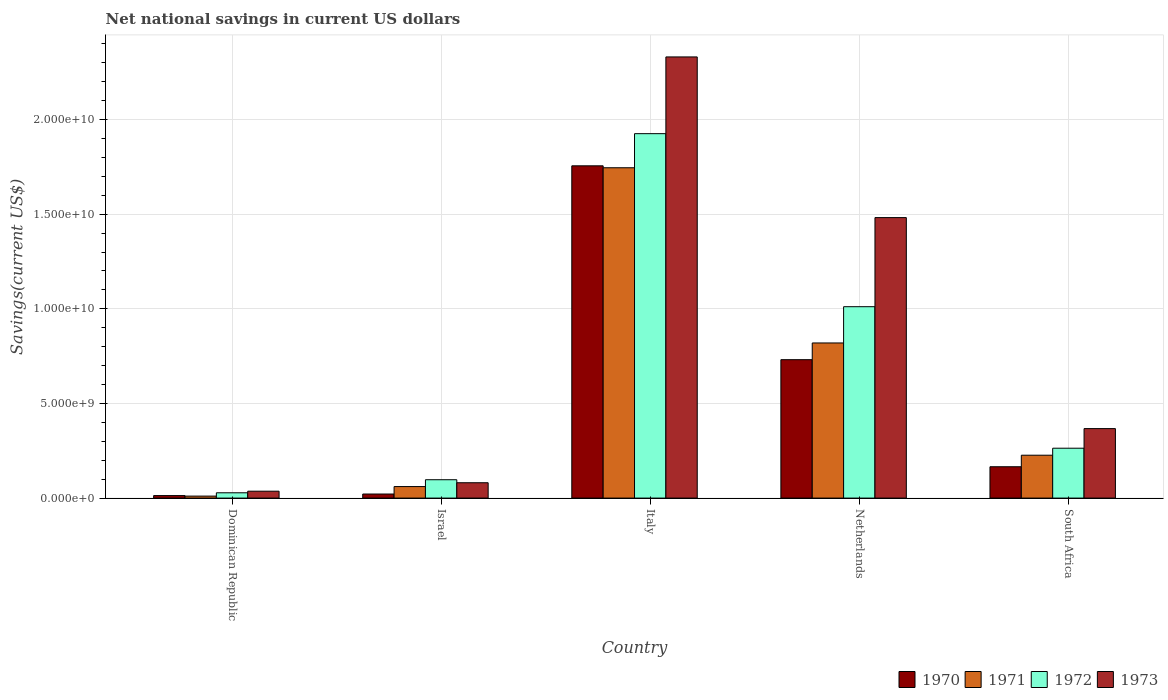How many different coloured bars are there?
Your answer should be compact. 4. How many groups of bars are there?
Offer a terse response. 5. How many bars are there on the 5th tick from the right?
Provide a short and direct response. 4. What is the label of the 1st group of bars from the left?
Your answer should be compact. Dominican Republic. In how many cases, is the number of bars for a given country not equal to the number of legend labels?
Your response must be concise. 0. What is the net national savings in 1972 in Italy?
Offer a very short reply. 1.93e+1. Across all countries, what is the maximum net national savings in 1972?
Ensure brevity in your answer.  1.93e+1. Across all countries, what is the minimum net national savings in 1972?
Offer a very short reply. 2.80e+08. In which country was the net national savings in 1973 maximum?
Your answer should be very brief. Italy. In which country was the net national savings in 1970 minimum?
Your response must be concise. Dominican Republic. What is the total net national savings in 1972 in the graph?
Make the answer very short. 3.33e+1. What is the difference between the net national savings in 1972 in Dominican Republic and that in Netherlands?
Your answer should be compact. -9.83e+09. What is the difference between the net national savings in 1970 in Italy and the net national savings in 1973 in Israel?
Your answer should be very brief. 1.67e+1. What is the average net national savings in 1973 per country?
Your answer should be compact. 8.59e+09. What is the difference between the net national savings of/in 1970 and net national savings of/in 1971 in Israel?
Ensure brevity in your answer.  -3.94e+08. In how many countries, is the net national savings in 1970 greater than 6000000000 US$?
Your response must be concise. 2. What is the ratio of the net national savings in 1971 in Israel to that in South Africa?
Your response must be concise. 0.27. Is the difference between the net national savings in 1970 in Dominican Republic and South Africa greater than the difference between the net national savings in 1971 in Dominican Republic and South Africa?
Offer a very short reply. Yes. What is the difference between the highest and the second highest net national savings in 1972?
Your answer should be very brief. -9.14e+09. What is the difference between the highest and the lowest net national savings in 1973?
Ensure brevity in your answer.  2.29e+1. What does the 1st bar from the left in Netherlands represents?
Offer a terse response. 1970. What does the 1st bar from the right in Dominican Republic represents?
Ensure brevity in your answer.  1973. How many bars are there?
Your response must be concise. 20. Are all the bars in the graph horizontal?
Your answer should be very brief. No. What is the difference between two consecutive major ticks on the Y-axis?
Provide a succinct answer. 5.00e+09. Are the values on the major ticks of Y-axis written in scientific E-notation?
Your answer should be very brief. Yes. Does the graph contain any zero values?
Offer a terse response. No. How many legend labels are there?
Your answer should be very brief. 4. How are the legend labels stacked?
Your response must be concise. Horizontal. What is the title of the graph?
Give a very brief answer. Net national savings in current US dollars. Does "1968" appear as one of the legend labels in the graph?
Offer a very short reply. No. What is the label or title of the Y-axis?
Your answer should be very brief. Savings(current US$). What is the Savings(current US$) in 1970 in Dominican Republic?
Your answer should be compact. 1.33e+08. What is the Savings(current US$) in 1971 in Dominican Republic?
Provide a short and direct response. 1.05e+08. What is the Savings(current US$) in 1972 in Dominican Republic?
Make the answer very short. 2.80e+08. What is the Savings(current US$) in 1973 in Dominican Republic?
Provide a short and direct response. 3.65e+08. What is the Savings(current US$) of 1970 in Israel?
Offer a terse response. 2.15e+08. What is the Savings(current US$) in 1971 in Israel?
Your answer should be very brief. 6.09e+08. What is the Savings(current US$) of 1972 in Israel?
Provide a succinct answer. 9.71e+08. What is the Savings(current US$) in 1973 in Israel?
Offer a terse response. 8.11e+08. What is the Savings(current US$) in 1970 in Italy?
Provide a succinct answer. 1.76e+1. What is the Savings(current US$) of 1971 in Italy?
Give a very brief answer. 1.75e+1. What is the Savings(current US$) in 1972 in Italy?
Provide a succinct answer. 1.93e+1. What is the Savings(current US$) in 1973 in Italy?
Make the answer very short. 2.33e+1. What is the Savings(current US$) of 1970 in Netherlands?
Offer a terse response. 7.31e+09. What is the Savings(current US$) in 1971 in Netherlands?
Provide a short and direct response. 8.20e+09. What is the Savings(current US$) of 1972 in Netherlands?
Offer a very short reply. 1.01e+1. What is the Savings(current US$) of 1973 in Netherlands?
Provide a short and direct response. 1.48e+1. What is the Savings(current US$) in 1970 in South Africa?
Make the answer very short. 1.66e+09. What is the Savings(current US$) of 1971 in South Africa?
Your answer should be very brief. 2.27e+09. What is the Savings(current US$) in 1972 in South Africa?
Make the answer very short. 2.64e+09. What is the Savings(current US$) in 1973 in South Africa?
Give a very brief answer. 3.67e+09. Across all countries, what is the maximum Savings(current US$) of 1970?
Give a very brief answer. 1.76e+1. Across all countries, what is the maximum Savings(current US$) in 1971?
Offer a very short reply. 1.75e+1. Across all countries, what is the maximum Savings(current US$) of 1972?
Provide a short and direct response. 1.93e+1. Across all countries, what is the maximum Savings(current US$) of 1973?
Offer a very short reply. 2.33e+1. Across all countries, what is the minimum Savings(current US$) in 1970?
Make the answer very short. 1.33e+08. Across all countries, what is the minimum Savings(current US$) of 1971?
Give a very brief answer. 1.05e+08. Across all countries, what is the minimum Savings(current US$) of 1972?
Make the answer very short. 2.80e+08. Across all countries, what is the minimum Savings(current US$) of 1973?
Your answer should be compact. 3.65e+08. What is the total Savings(current US$) of 1970 in the graph?
Provide a short and direct response. 2.69e+1. What is the total Savings(current US$) of 1971 in the graph?
Give a very brief answer. 2.86e+1. What is the total Savings(current US$) in 1972 in the graph?
Offer a very short reply. 3.33e+1. What is the total Savings(current US$) of 1973 in the graph?
Provide a short and direct response. 4.30e+1. What is the difference between the Savings(current US$) in 1970 in Dominican Republic and that in Israel?
Your answer should be very brief. -8.19e+07. What is the difference between the Savings(current US$) in 1971 in Dominican Republic and that in Israel?
Provide a succinct answer. -5.03e+08. What is the difference between the Savings(current US$) of 1972 in Dominican Republic and that in Israel?
Provide a succinct answer. -6.90e+08. What is the difference between the Savings(current US$) in 1973 in Dominican Republic and that in Israel?
Ensure brevity in your answer.  -4.46e+08. What is the difference between the Savings(current US$) in 1970 in Dominican Republic and that in Italy?
Your response must be concise. -1.74e+1. What is the difference between the Savings(current US$) of 1971 in Dominican Republic and that in Italy?
Provide a succinct answer. -1.73e+1. What is the difference between the Savings(current US$) of 1972 in Dominican Republic and that in Italy?
Offer a terse response. -1.90e+1. What is the difference between the Savings(current US$) of 1973 in Dominican Republic and that in Italy?
Give a very brief answer. -2.29e+1. What is the difference between the Savings(current US$) of 1970 in Dominican Republic and that in Netherlands?
Your answer should be very brief. -7.18e+09. What is the difference between the Savings(current US$) in 1971 in Dominican Republic and that in Netherlands?
Offer a very short reply. -8.09e+09. What is the difference between the Savings(current US$) in 1972 in Dominican Republic and that in Netherlands?
Make the answer very short. -9.83e+09. What is the difference between the Savings(current US$) in 1973 in Dominican Republic and that in Netherlands?
Your response must be concise. -1.45e+1. What is the difference between the Savings(current US$) of 1970 in Dominican Republic and that in South Africa?
Give a very brief answer. -1.52e+09. What is the difference between the Savings(current US$) of 1971 in Dominican Republic and that in South Africa?
Offer a terse response. -2.16e+09. What is the difference between the Savings(current US$) in 1972 in Dominican Republic and that in South Africa?
Give a very brief answer. -2.35e+09. What is the difference between the Savings(current US$) in 1973 in Dominican Republic and that in South Africa?
Your response must be concise. -3.31e+09. What is the difference between the Savings(current US$) of 1970 in Israel and that in Italy?
Keep it short and to the point. -1.73e+1. What is the difference between the Savings(current US$) in 1971 in Israel and that in Italy?
Your answer should be compact. -1.68e+1. What is the difference between the Savings(current US$) of 1972 in Israel and that in Italy?
Offer a very short reply. -1.83e+1. What is the difference between the Savings(current US$) in 1973 in Israel and that in Italy?
Make the answer very short. -2.25e+1. What is the difference between the Savings(current US$) in 1970 in Israel and that in Netherlands?
Provide a succinct answer. -7.10e+09. What is the difference between the Savings(current US$) of 1971 in Israel and that in Netherlands?
Provide a succinct answer. -7.59e+09. What is the difference between the Savings(current US$) of 1972 in Israel and that in Netherlands?
Give a very brief answer. -9.14e+09. What is the difference between the Savings(current US$) of 1973 in Israel and that in Netherlands?
Offer a terse response. -1.40e+1. What is the difference between the Savings(current US$) in 1970 in Israel and that in South Africa?
Ensure brevity in your answer.  -1.44e+09. What is the difference between the Savings(current US$) of 1971 in Israel and that in South Africa?
Provide a short and direct response. -1.66e+09. What is the difference between the Savings(current US$) in 1972 in Israel and that in South Africa?
Your response must be concise. -1.66e+09. What is the difference between the Savings(current US$) of 1973 in Israel and that in South Africa?
Keep it short and to the point. -2.86e+09. What is the difference between the Savings(current US$) of 1970 in Italy and that in Netherlands?
Offer a terse response. 1.02e+1. What is the difference between the Savings(current US$) of 1971 in Italy and that in Netherlands?
Offer a terse response. 9.26e+09. What is the difference between the Savings(current US$) of 1972 in Italy and that in Netherlands?
Give a very brief answer. 9.14e+09. What is the difference between the Savings(current US$) in 1973 in Italy and that in Netherlands?
Your response must be concise. 8.49e+09. What is the difference between the Savings(current US$) in 1970 in Italy and that in South Africa?
Offer a terse response. 1.59e+1. What is the difference between the Savings(current US$) of 1971 in Italy and that in South Africa?
Offer a terse response. 1.52e+1. What is the difference between the Savings(current US$) of 1972 in Italy and that in South Africa?
Your response must be concise. 1.66e+1. What is the difference between the Savings(current US$) in 1973 in Italy and that in South Africa?
Your response must be concise. 1.96e+1. What is the difference between the Savings(current US$) of 1970 in Netherlands and that in South Africa?
Make the answer very short. 5.66e+09. What is the difference between the Savings(current US$) of 1971 in Netherlands and that in South Africa?
Make the answer very short. 5.93e+09. What is the difference between the Savings(current US$) in 1972 in Netherlands and that in South Africa?
Provide a short and direct response. 7.48e+09. What is the difference between the Savings(current US$) in 1973 in Netherlands and that in South Africa?
Keep it short and to the point. 1.11e+1. What is the difference between the Savings(current US$) of 1970 in Dominican Republic and the Savings(current US$) of 1971 in Israel?
Your response must be concise. -4.76e+08. What is the difference between the Savings(current US$) of 1970 in Dominican Republic and the Savings(current US$) of 1972 in Israel?
Provide a short and direct response. -8.38e+08. What is the difference between the Savings(current US$) in 1970 in Dominican Republic and the Savings(current US$) in 1973 in Israel?
Your response must be concise. -6.78e+08. What is the difference between the Savings(current US$) of 1971 in Dominican Republic and the Savings(current US$) of 1972 in Israel?
Your response must be concise. -8.65e+08. What is the difference between the Savings(current US$) in 1971 in Dominican Republic and the Savings(current US$) in 1973 in Israel?
Give a very brief answer. -7.05e+08. What is the difference between the Savings(current US$) in 1972 in Dominican Republic and the Savings(current US$) in 1973 in Israel?
Offer a terse response. -5.30e+08. What is the difference between the Savings(current US$) of 1970 in Dominican Republic and the Savings(current US$) of 1971 in Italy?
Your answer should be compact. -1.73e+1. What is the difference between the Savings(current US$) in 1970 in Dominican Republic and the Savings(current US$) in 1972 in Italy?
Your response must be concise. -1.91e+1. What is the difference between the Savings(current US$) in 1970 in Dominican Republic and the Savings(current US$) in 1973 in Italy?
Offer a terse response. -2.32e+1. What is the difference between the Savings(current US$) in 1971 in Dominican Republic and the Savings(current US$) in 1972 in Italy?
Make the answer very short. -1.91e+1. What is the difference between the Savings(current US$) of 1971 in Dominican Republic and the Savings(current US$) of 1973 in Italy?
Make the answer very short. -2.32e+1. What is the difference between the Savings(current US$) in 1972 in Dominican Republic and the Savings(current US$) in 1973 in Italy?
Ensure brevity in your answer.  -2.30e+1. What is the difference between the Savings(current US$) of 1970 in Dominican Republic and the Savings(current US$) of 1971 in Netherlands?
Ensure brevity in your answer.  -8.06e+09. What is the difference between the Savings(current US$) in 1970 in Dominican Republic and the Savings(current US$) in 1972 in Netherlands?
Offer a very short reply. -9.98e+09. What is the difference between the Savings(current US$) in 1970 in Dominican Republic and the Savings(current US$) in 1973 in Netherlands?
Keep it short and to the point. -1.47e+1. What is the difference between the Savings(current US$) of 1971 in Dominican Republic and the Savings(current US$) of 1972 in Netherlands?
Keep it short and to the point. -1.00e+1. What is the difference between the Savings(current US$) in 1971 in Dominican Republic and the Savings(current US$) in 1973 in Netherlands?
Your answer should be very brief. -1.47e+1. What is the difference between the Savings(current US$) of 1972 in Dominican Republic and the Savings(current US$) of 1973 in Netherlands?
Your answer should be compact. -1.45e+1. What is the difference between the Savings(current US$) of 1970 in Dominican Republic and the Savings(current US$) of 1971 in South Africa?
Keep it short and to the point. -2.13e+09. What is the difference between the Savings(current US$) in 1970 in Dominican Republic and the Savings(current US$) in 1972 in South Africa?
Keep it short and to the point. -2.50e+09. What is the difference between the Savings(current US$) of 1970 in Dominican Republic and the Savings(current US$) of 1973 in South Africa?
Your answer should be compact. -3.54e+09. What is the difference between the Savings(current US$) in 1971 in Dominican Republic and the Savings(current US$) in 1972 in South Africa?
Provide a short and direct response. -2.53e+09. What is the difference between the Savings(current US$) of 1971 in Dominican Republic and the Savings(current US$) of 1973 in South Africa?
Provide a short and direct response. -3.57e+09. What is the difference between the Savings(current US$) of 1972 in Dominican Republic and the Savings(current US$) of 1973 in South Africa?
Your answer should be very brief. -3.39e+09. What is the difference between the Savings(current US$) in 1970 in Israel and the Savings(current US$) in 1971 in Italy?
Keep it short and to the point. -1.72e+1. What is the difference between the Savings(current US$) in 1970 in Israel and the Savings(current US$) in 1972 in Italy?
Your answer should be compact. -1.90e+1. What is the difference between the Savings(current US$) of 1970 in Israel and the Savings(current US$) of 1973 in Italy?
Provide a short and direct response. -2.31e+1. What is the difference between the Savings(current US$) in 1971 in Israel and the Savings(current US$) in 1972 in Italy?
Give a very brief answer. -1.86e+1. What is the difference between the Savings(current US$) of 1971 in Israel and the Savings(current US$) of 1973 in Italy?
Keep it short and to the point. -2.27e+1. What is the difference between the Savings(current US$) of 1972 in Israel and the Savings(current US$) of 1973 in Italy?
Keep it short and to the point. -2.23e+1. What is the difference between the Savings(current US$) of 1970 in Israel and the Savings(current US$) of 1971 in Netherlands?
Offer a terse response. -7.98e+09. What is the difference between the Savings(current US$) in 1970 in Israel and the Savings(current US$) in 1972 in Netherlands?
Give a very brief answer. -9.90e+09. What is the difference between the Savings(current US$) of 1970 in Israel and the Savings(current US$) of 1973 in Netherlands?
Ensure brevity in your answer.  -1.46e+1. What is the difference between the Savings(current US$) of 1971 in Israel and the Savings(current US$) of 1972 in Netherlands?
Your response must be concise. -9.50e+09. What is the difference between the Savings(current US$) of 1971 in Israel and the Savings(current US$) of 1973 in Netherlands?
Ensure brevity in your answer.  -1.42e+1. What is the difference between the Savings(current US$) in 1972 in Israel and the Savings(current US$) in 1973 in Netherlands?
Provide a short and direct response. -1.38e+1. What is the difference between the Savings(current US$) of 1970 in Israel and the Savings(current US$) of 1971 in South Africa?
Provide a short and direct response. -2.05e+09. What is the difference between the Savings(current US$) of 1970 in Israel and the Savings(current US$) of 1972 in South Africa?
Keep it short and to the point. -2.42e+09. What is the difference between the Savings(current US$) in 1970 in Israel and the Savings(current US$) in 1973 in South Africa?
Keep it short and to the point. -3.46e+09. What is the difference between the Savings(current US$) in 1971 in Israel and the Savings(current US$) in 1972 in South Africa?
Provide a short and direct response. -2.03e+09. What is the difference between the Savings(current US$) in 1971 in Israel and the Savings(current US$) in 1973 in South Africa?
Your response must be concise. -3.06e+09. What is the difference between the Savings(current US$) of 1972 in Israel and the Savings(current US$) of 1973 in South Africa?
Your answer should be very brief. -2.70e+09. What is the difference between the Savings(current US$) in 1970 in Italy and the Savings(current US$) in 1971 in Netherlands?
Your answer should be very brief. 9.36e+09. What is the difference between the Savings(current US$) of 1970 in Italy and the Savings(current US$) of 1972 in Netherlands?
Ensure brevity in your answer.  7.44e+09. What is the difference between the Savings(current US$) of 1970 in Italy and the Savings(current US$) of 1973 in Netherlands?
Ensure brevity in your answer.  2.74e+09. What is the difference between the Savings(current US$) of 1971 in Italy and the Savings(current US$) of 1972 in Netherlands?
Keep it short and to the point. 7.34e+09. What is the difference between the Savings(current US$) of 1971 in Italy and the Savings(current US$) of 1973 in Netherlands?
Your answer should be very brief. 2.63e+09. What is the difference between the Savings(current US$) in 1972 in Italy and the Savings(current US$) in 1973 in Netherlands?
Make the answer very short. 4.44e+09. What is the difference between the Savings(current US$) of 1970 in Italy and the Savings(current US$) of 1971 in South Africa?
Your answer should be compact. 1.53e+1. What is the difference between the Savings(current US$) of 1970 in Italy and the Savings(current US$) of 1972 in South Africa?
Provide a succinct answer. 1.49e+1. What is the difference between the Savings(current US$) in 1970 in Italy and the Savings(current US$) in 1973 in South Africa?
Provide a short and direct response. 1.39e+1. What is the difference between the Savings(current US$) in 1971 in Italy and the Savings(current US$) in 1972 in South Africa?
Your response must be concise. 1.48e+1. What is the difference between the Savings(current US$) of 1971 in Italy and the Savings(current US$) of 1973 in South Africa?
Make the answer very short. 1.38e+1. What is the difference between the Savings(current US$) of 1972 in Italy and the Savings(current US$) of 1973 in South Africa?
Offer a terse response. 1.56e+1. What is the difference between the Savings(current US$) of 1970 in Netherlands and the Savings(current US$) of 1971 in South Africa?
Make the answer very short. 5.05e+09. What is the difference between the Savings(current US$) in 1970 in Netherlands and the Savings(current US$) in 1972 in South Africa?
Offer a very short reply. 4.68e+09. What is the difference between the Savings(current US$) of 1970 in Netherlands and the Savings(current US$) of 1973 in South Africa?
Provide a short and direct response. 3.64e+09. What is the difference between the Savings(current US$) in 1971 in Netherlands and the Savings(current US$) in 1972 in South Africa?
Make the answer very short. 5.56e+09. What is the difference between the Savings(current US$) of 1971 in Netherlands and the Savings(current US$) of 1973 in South Africa?
Provide a short and direct response. 4.52e+09. What is the difference between the Savings(current US$) of 1972 in Netherlands and the Savings(current US$) of 1973 in South Africa?
Your answer should be very brief. 6.44e+09. What is the average Savings(current US$) in 1970 per country?
Your answer should be very brief. 5.37e+09. What is the average Savings(current US$) of 1971 per country?
Ensure brevity in your answer.  5.73e+09. What is the average Savings(current US$) in 1972 per country?
Make the answer very short. 6.65e+09. What is the average Savings(current US$) of 1973 per country?
Your response must be concise. 8.59e+09. What is the difference between the Savings(current US$) in 1970 and Savings(current US$) in 1971 in Dominican Republic?
Provide a short and direct response. 2.74e+07. What is the difference between the Savings(current US$) in 1970 and Savings(current US$) in 1972 in Dominican Republic?
Make the answer very short. -1.48e+08. What is the difference between the Savings(current US$) of 1970 and Savings(current US$) of 1973 in Dominican Republic?
Your response must be concise. -2.32e+08. What is the difference between the Savings(current US$) of 1971 and Savings(current US$) of 1972 in Dominican Republic?
Make the answer very short. -1.75e+08. What is the difference between the Savings(current US$) in 1971 and Savings(current US$) in 1973 in Dominican Republic?
Keep it short and to the point. -2.59e+08. What is the difference between the Savings(current US$) of 1972 and Savings(current US$) of 1973 in Dominican Republic?
Make the answer very short. -8.40e+07. What is the difference between the Savings(current US$) of 1970 and Savings(current US$) of 1971 in Israel?
Your response must be concise. -3.94e+08. What is the difference between the Savings(current US$) of 1970 and Savings(current US$) of 1972 in Israel?
Your answer should be very brief. -7.56e+08. What is the difference between the Savings(current US$) of 1970 and Savings(current US$) of 1973 in Israel?
Your answer should be very brief. -5.96e+08. What is the difference between the Savings(current US$) of 1971 and Savings(current US$) of 1972 in Israel?
Provide a short and direct response. -3.62e+08. What is the difference between the Savings(current US$) in 1971 and Savings(current US$) in 1973 in Israel?
Make the answer very short. -2.02e+08. What is the difference between the Savings(current US$) in 1972 and Savings(current US$) in 1973 in Israel?
Provide a short and direct response. 1.60e+08. What is the difference between the Savings(current US$) of 1970 and Savings(current US$) of 1971 in Italy?
Your answer should be compact. 1.03e+08. What is the difference between the Savings(current US$) in 1970 and Savings(current US$) in 1972 in Italy?
Provide a succinct answer. -1.70e+09. What is the difference between the Savings(current US$) in 1970 and Savings(current US$) in 1973 in Italy?
Make the answer very short. -5.75e+09. What is the difference between the Savings(current US$) in 1971 and Savings(current US$) in 1972 in Italy?
Your answer should be very brief. -1.80e+09. What is the difference between the Savings(current US$) in 1971 and Savings(current US$) in 1973 in Italy?
Your answer should be compact. -5.86e+09. What is the difference between the Savings(current US$) in 1972 and Savings(current US$) in 1973 in Italy?
Keep it short and to the point. -4.05e+09. What is the difference between the Savings(current US$) in 1970 and Savings(current US$) in 1971 in Netherlands?
Your response must be concise. -8.83e+08. What is the difference between the Savings(current US$) of 1970 and Savings(current US$) of 1972 in Netherlands?
Your answer should be compact. -2.80e+09. What is the difference between the Savings(current US$) in 1970 and Savings(current US$) in 1973 in Netherlands?
Ensure brevity in your answer.  -7.51e+09. What is the difference between the Savings(current US$) in 1971 and Savings(current US$) in 1972 in Netherlands?
Ensure brevity in your answer.  -1.92e+09. What is the difference between the Savings(current US$) of 1971 and Savings(current US$) of 1973 in Netherlands?
Offer a terse response. -6.62e+09. What is the difference between the Savings(current US$) of 1972 and Savings(current US$) of 1973 in Netherlands?
Ensure brevity in your answer.  -4.71e+09. What is the difference between the Savings(current US$) of 1970 and Savings(current US$) of 1971 in South Africa?
Ensure brevity in your answer.  -6.09e+08. What is the difference between the Savings(current US$) in 1970 and Savings(current US$) in 1972 in South Africa?
Give a very brief answer. -9.79e+08. What is the difference between the Savings(current US$) in 1970 and Savings(current US$) in 1973 in South Africa?
Your answer should be very brief. -2.02e+09. What is the difference between the Savings(current US$) in 1971 and Savings(current US$) in 1972 in South Africa?
Make the answer very short. -3.70e+08. What is the difference between the Savings(current US$) of 1971 and Savings(current US$) of 1973 in South Africa?
Provide a succinct answer. -1.41e+09. What is the difference between the Savings(current US$) in 1972 and Savings(current US$) in 1973 in South Africa?
Ensure brevity in your answer.  -1.04e+09. What is the ratio of the Savings(current US$) in 1970 in Dominican Republic to that in Israel?
Your answer should be compact. 0.62. What is the ratio of the Savings(current US$) of 1971 in Dominican Republic to that in Israel?
Provide a short and direct response. 0.17. What is the ratio of the Savings(current US$) of 1972 in Dominican Republic to that in Israel?
Offer a terse response. 0.29. What is the ratio of the Savings(current US$) in 1973 in Dominican Republic to that in Israel?
Your response must be concise. 0.45. What is the ratio of the Savings(current US$) of 1970 in Dominican Republic to that in Italy?
Offer a terse response. 0.01. What is the ratio of the Savings(current US$) of 1971 in Dominican Republic to that in Italy?
Keep it short and to the point. 0.01. What is the ratio of the Savings(current US$) of 1972 in Dominican Republic to that in Italy?
Your answer should be compact. 0.01. What is the ratio of the Savings(current US$) of 1973 in Dominican Republic to that in Italy?
Offer a very short reply. 0.02. What is the ratio of the Savings(current US$) of 1970 in Dominican Republic to that in Netherlands?
Offer a very short reply. 0.02. What is the ratio of the Savings(current US$) of 1971 in Dominican Republic to that in Netherlands?
Your response must be concise. 0.01. What is the ratio of the Savings(current US$) in 1972 in Dominican Republic to that in Netherlands?
Make the answer very short. 0.03. What is the ratio of the Savings(current US$) in 1973 in Dominican Republic to that in Netherlands?
Make the answer very short. 0.02. What is the ratio of the Savings(current US$) in 1970 in Dominican Republic to that in South Africa?
Your answer should be compact. 0.08. What is the ratio of the Savings(current US$) in 1971 in Dominican Republic to that in South Africa?
Offer a terse response. 0.05. What is the ratio of the Savings(current US$) in 1972 in Dominican Republic to that in South Africa?
Offer a very short reply. 0.11. What is the ratio of the Savings(current US$) of 1973 in Dominican Republic to that in South Africa?
Your response must be concise. 0.1. What is the ratio of the Savings(current US$) of 1970 in Israel to that in Italy?
Make the answer very short. 0.01. What is the ratio of the Savings(current US$) of 1971 in Israel to that in Italy?
Ensure brevity in your answer.  0.03. What is the ratio of the Savings(current US$) of 1972 in Israel to that in Italy?
Offer a terse response. 0.05. What is the ratio of the Savings(current US$) of 1973 in Israel to that in Italy?
Offer a very short reply. 0.03. What is the ratio of the Savings(current US$) of 1970 in Israel to that in Netherlands?
Offer a terse response. 0.03. What is the ratio of the Savings(current US$) in 1971 in Israel to that in Netherlands?
Make the answer very short. 0.07. What is the ratio of the Savings(current US$) of 1972 in Israel to that in Netherlands?
Ensure brevity in your answer.  0.1. What is the ratio of the Savings(current US$) of 1973 in Israel to that in Netherlands?
Keep it short and to the point. 0.05. What is the ratio of the Savings(current US$) in 1970 in Israel to that in South Africa?
Make the answer very short. 0.13. What is the ratio of the Savings(current US$) of 1971 in Israel to that in South Africa?
Provide a succinct answer. 0.27. What is the ratio of the Savings(current US$) of 1972 in Israel to that in South Africa?
Make the answer very short. 0.37. What is the ratio of the Savings(current US$) in 1973 in Israel to that in South Africa?
Make the answer very short. 0.22. What is the ratio of the Savings(current US$) in 1970 in Italy to that in Netherlands?
Keep it short and to the point. 2.4. What is the ratio of the Savings(current US$) of 1971 in Italy to that in Netherlands?
Your response must be concise. 2.13. What is the ratio of the Savings(current US$) of 1972 in Italy to that in Netherlands?
Offer a very short reply. 1.9. What is the ratio of the Savings(current US$) of 1973 in Italy to that in Netherlands?
Give a very brief answer. 1.57. What is the ratio of the Savings(current US$) of 1970 in Italy to that in South Africa?
Your answer should be compact. 10.6. What is the ratio of the Savings(current US$) in 1971 in Italy to that in South Africa?
Offer a very short reply. 7.7. What is the ratio of the Savings(current US$) in 1972 in Italy to that in South Africa?
Your answer should be very brief. 7.31. What is the ratio of the Savings(current US$) in 1973 in Italy to that in South Africa?
Your answer should be compact. 6.35. What is the ratio of the Savings(current US$) in 1970 in Netherlands to that in South Africa?
Make the answer very short. 4.42. What is the ratio of the Savings(current US$) in 1971 in Netherlands to that in South Africa?
Provide a succinct answer. 3.62. What is the ratio of the Savings(current US$) in 1972 in Netherlands to that in South Africa?
Make the answer very short. 3.84. What is the ratio of the Savings(current US$) in 1973 in Netherlands to that in South Africa?
Your answer should be compact. 4.04. What is the difference between the highest and the second highest Savings(current US$) of 1970?
Keep it short and to the point. 1.02e+1. What is the difference between the highest and the second highest Savings(current US$) in 1971?
Offer a very short reply. 9.26e+09. What is the difference between the highest and the second highest Savings(current US$) in 1972?
Provide a succinct answer. 9.14e+09. What is the difference between the highest and the second highest Savings(current US$) of 1973?
Offer a very short reply. 8.49e+09. What is the difference between the highest and the lowest Savings(current US$) of 1970?
Offer a terse response. 1.74e+1. What is the difference between the highest and the lowest Savings(current US$) of 1971?
Your response must be concise. 1.73e+1. What is the difference between the highest and the lowest Savings(current US$) in 1972?
Your answer should be very brief. 1.90e+1. What is the difference between the highest and the lowest Savings(current US$) of 1973?
Keep it short and to the point. 2.29e+1. 